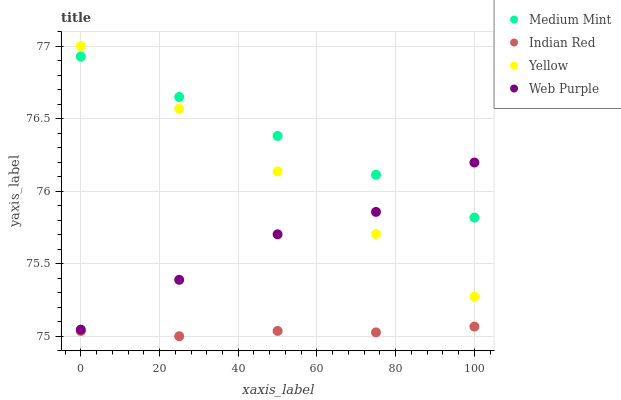Does Indian Red have the minimum area under the curve?
Answer yes or no. Yes. Does Medium Mint have the maximum area under the curve?
Answer yes or no. Yes. Does Web Purple have the minimum area under the curve?
Answer yes or no. No. Does Web Purple have the maximum area under the curve?
Answer yes or no. No. Is Yellow the smoothest?
Answer yes or no. Yes. Is Web Purple the roughest?
Answer yes or no. Yes. Is Web Purple the smoothest?
Answer yes or no. No. Is Yellow the roughest?
Answer yes or no. No. Does Indian Red have the lowest value?
Answer yes or no. Yes. Does Web Purple have the lowest value?
Answer yes or no. No. Does Yellow have the highest value?
Answer yes or no. Yes. Does Web Purple have the highest value?
Answer yes or no. No. Is Indian Red less than Yellow?
Answer yes or no. Yes. Is Medium Mint greater than Indian Red?
Answer yes or no. Yes. Does Yellow intersect Medium Mint?
Answer yes or no. Yes. Is Yellow less than Medium Mint?
Answer yes or no. No. Is Yellow greater than Medium Mint?
Answer yes or no. No. Does Indian Red intersect Yellow?
Answer yes or no. No. 